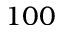<formula> <loc_0><loc_0><loc_500><loc_500>1 0 0</formula> 